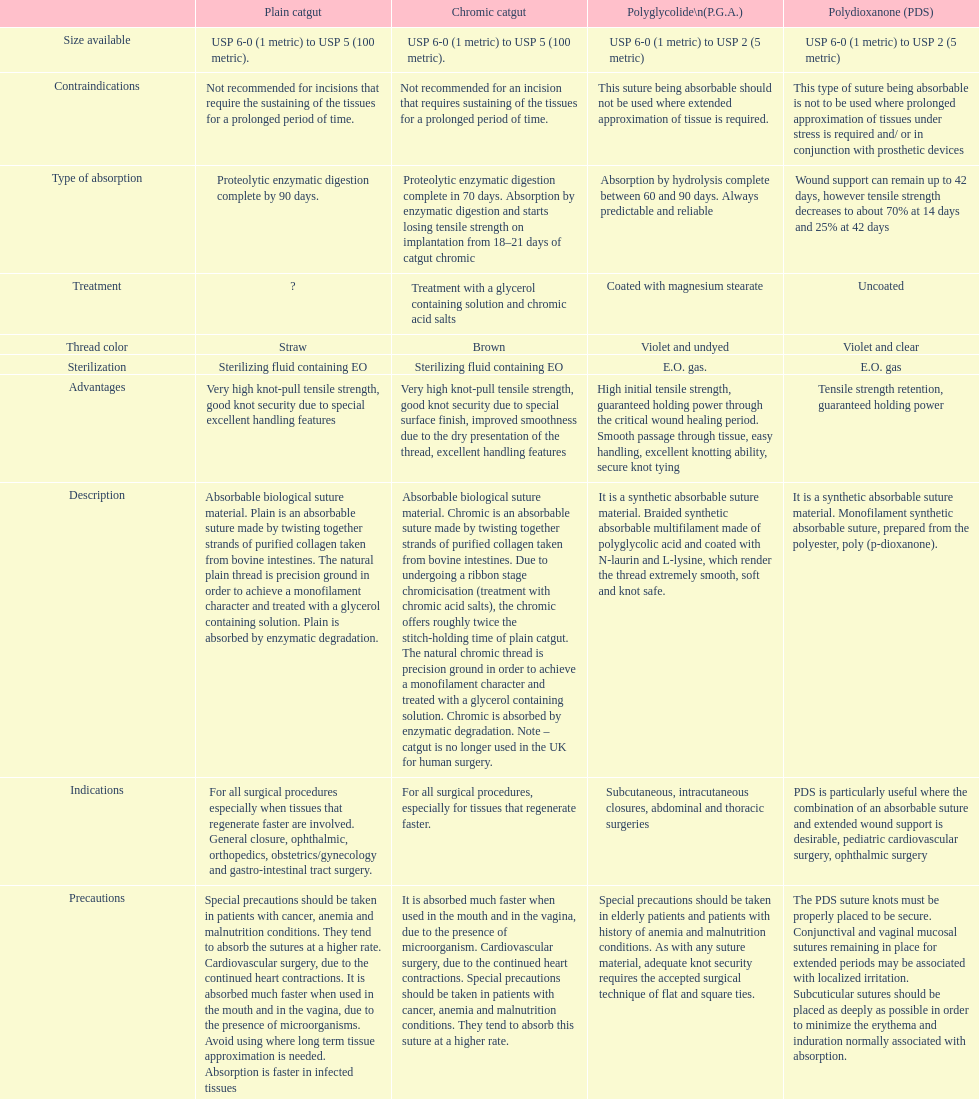What type of sutures are no longer used in the u.k. for human surgery? Chromic catgut. 